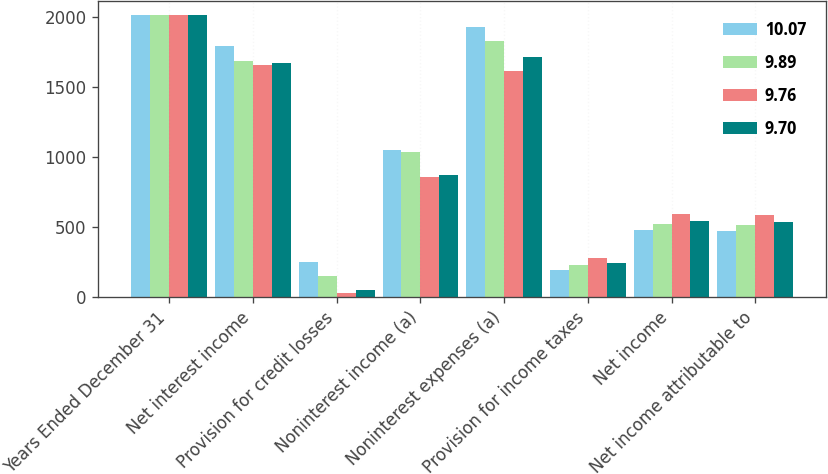Convert chart to OTSL. <chart><loc_0><loc_0><loc_500><loc_500><stacked_bar_chart><ecel><fcel>Years Ended December 31<fcel>Net interest income<fcel>Provision for credit losses<fcel>Noninterest income (a)<fcel>Noninterest expenses (a)<fcel>Provision for income taxes<fcel>Net income<fcel>Net income attributable to<nl><fcel>10.07<fcel>2016<fcel>1797<fcel>248<fcel>1051<fcel>1930<fcel>193<fcel>477<fcel>473<nl><fcel>9.89<fcel>2015<fcel>1689<fcel>147<fcel>1035<fcel>1827<fcel>229<fcel>521<fcel>515<nl><fcel>9.76<fcel>2014<fcel>1655<fcel>27<fcel>857<fcel>1615<fcel>277<fcel>593<fcel>586<nl><fcel>9.7<fcel>2013<fcel>1672<fcel>46<fcel>874<fcel>1714<fcel>245<fcel>541<fcel>533<nl></chart> 